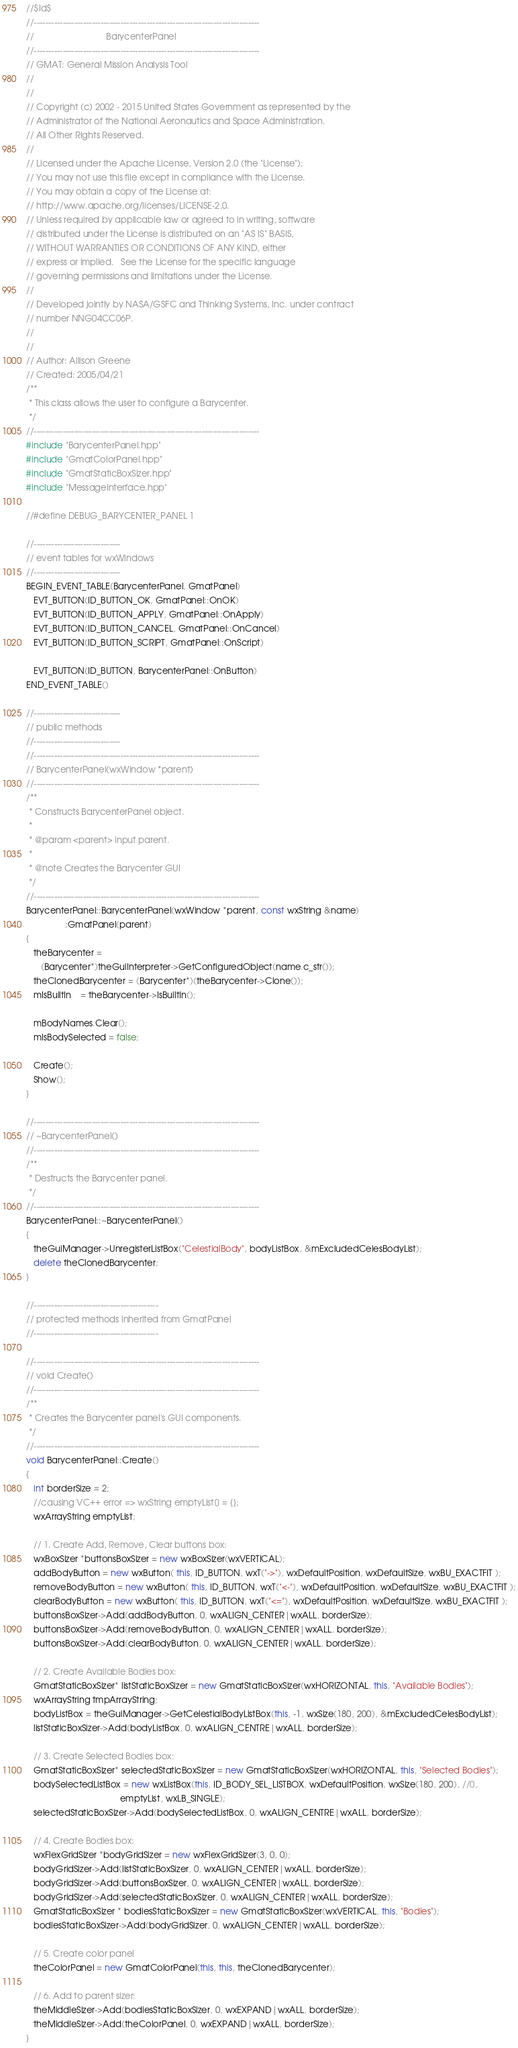Convert code to text. <code><loc_0><loc_0><loc_500><loc_500><_C++_>//$Id$
//------------------------------------------------------------------------------
//                              BarycenterPanel
//------------------------------------------------------------------------------
// GMAT: General Mission Analysis Tool
//
//
// Copyright (c) 2002 - 2015 United States Government as represented by the
// Administrator of the National Aeronautics and Space Administration.
// All Other Rights Reserved.
//
// Licensed under the Apache License, Version 2.0 (the "License"); 
// You may not use this file except in compliance with the License. 
// You may obtain a copy of the License at:
// http://www.apache.org/licenses/LICENSE-2.0. 
// Unless required by applicable law or agreed to in writing, software
// distributed under the License is distributed on an "AS IS" BASIS,
// WITHOUT WARRANTIES OR CONDITIONS OF ANY KIND, either 
// express or implied.   See the License for the specific language
// governing permissions and limitations under the License.
//
// Developed jointly by NASA/GSFC and Thinking Systems, Inc. under contract
// number NNG04CC06P.
//
//
// Author: Allison Greene
// Created: 2005/04/21
/**
 * This class allows the user to configure a Barycenter.
 */
//------------------------------------------------------------------------------
#include "BarycenterPanel.hpp"
#include "GmatColorPanel.hpp"
#include "GmatStaticBoxSizer.hpp"
#include "MessageInterface.hpp"

//#define DEBUG_BARYCENTER_PANEL 1

//------------------------------
// event tables for wxWindows
//------------------------------
BEGIN_EVENT_TABLE(BarycenterPanel, GmatPanel)
   EVT_BUTTON(ID_BUTTON_OK, GmatPanel::OnOK)
   EVT_BUTTON(ID_BUTTON_APPLY, GmatPanel::OnApply)
   EVT_BUTTON(ID_BUTTON_CANCEL, GmatPanel::OnCancel)
   EVT_BUTTON(ID_BUTTON_SCRIPT, GmatPanel::OnScript)

   EVT_BUTTON(ID_BUTTON, BarycenterPanel::OnButton)
END_EVENT_TABLE()

//------------------------------
// public methods
//------------------------------
//------------------------------------------------------------------------------
// BarycenterPanel(wxWindow *parent)
//------------------------------------------------------------------------------
/**
 * Constructs BarycenterPanel object.
 *
 * @param <parent> input parent.
 *
 * @note Creates the Barycenter GUI
 */
//------------------------------------------------------------------------------
BarycenterPanel::BarycenterPanel(wxWindow *parent, const wxString &name)
                :GmatPanel(parent)
{
   theBarycenter =
      (Barycenter*)theGuiInterpreter->GetConfiguredObject(name.c_str());
   theClonedBarycenter = (Barycenter*)(theBarycenter->Clone());
   mIsBuiltIn    = theBarycenter->IsBuiltIn();
   
   mBodyNames.Clear();
   mIsBodySelected = false;
   
   Create();
   Show();
}

//------------------------------------------------------------------------------
// ~BarycenterPanel()
//------------------------------------------------------------------------------
/**
 * Destructs the Barycenter panel.
 */
//------------------------------------------------------------------------------
BarycenterPanel::~BarycenterPanel()
{
   theGuiManager->UnregisterListBox("CelestialBody", bodyListBox, &mExcludedCelesBodyList);
   delete theClonedBarycenter;
}

//-------------------------------------------
// protected methods inherited from GmatPanel
//-------------------------------------------

//------------------------------------------------------------------------------
// void Create()
//------------------------------------------------------------------------------
/**
 * Creates the Barycenter panel's GUI components.
 */
//------------------------------------------------------------------------------
void BarycenterPanel::Create()
{
   int borderSize = 2;
   //causing VC++ error => wxString emptyList[] = {};
   wxArrayString emptyList;
   
   // 1. Create Add, Remove, Clear buttons box:
   wxBoxSizer *buttonsBoxSizer = new wxBoxSizer(wxVERTICAL);
   addBodyButton = new wxButton( this, ID_BUTTON, wxT("->"), wxDefaultPosition, wxDefaultSize, wxBU_EXACTFIT );
   removeBodyButton = new wxButton( this, ID_BUTTON, wxT("<-"), wxDefaultPosition, wxDefaultSize, wxBU_EXACTFIT );
   clearBodyButton = new wxButton( this, ID_BUTTON, wxT("<="), wxDefaultPosition, wxDefaultSize, wxBU_EXACTFIT );
   buttonsBoxSizer->Add(addBodyButton, 0, wxALIGN_CENTER|wxALL, borderSize);
   buttonsBoxSizer->Add(removeBodyButton, 0, wxALIGN_CENTER|wxALL, borderSize);
   buttonsBoxSizer->Add(clearBodyButton, 0, wxALIGN_CENTER|wxALL, borderSize);
   
   // 2. Create Available Bodies box:
   GmatStaticBoxSizer* listStaticBoxSizer = new GmatStaticBoxSizer(wxHORIZONTAL, this, "Available Bodies");
   wxArrayString tmpArrayString;
   bodyListBox = theGuiManager->GetCelestialBodyListBox(this, -1, wxSize(180, 200), &mExcludedCelesBodyList);
   listStaticBoxSizer->Add(bodyListBox, 0, wxALIGN_CENTRE|wxALL, borderSize);
   
   // 3. Create Selected Bodies box:
   GmatStaticBoxSizer* selectedStaticBoxSizer = new GmatStaticBoxSizer(wxHORIZONTAL, this, "Selected Bodies");
   bodySelectedListBox = new wxListBox(this, ID_BODY_SEL_LISTBOX, wxDefaultPosition, wxSize(180, 200), //0,
                                       emptyList, wxLB_SINGLE);
   selectedStaticBoxSizer->Add(bodySelectedListBox, 0, wxALIGN_CENTRE|wxALL, borderSize);
   
   // 4. Create Bodies box:
   wxFlexGridSizer *bodyGridSizer = new wxFlexGridSizer(3, 0, 0);
   bodyGridSizer->Add(listStaticBoxSizer, 0, wxALIGN_CENTER|wxALL, borderSize);
   bodyGridSizer->Add(buttonsBoxSizer, 0, wxALIGN_CENTER|wxALL, borderSize);
   bodyGridSizer->Add(selectedStaticBoxSizer, 0, wxALIGN_CENTER|wxALL, borderSize);
   GmatStaticBoxSizer * bodiesStaticBoxSizer = new GmatStaticBoxSizer(wxVERTICAL, this, "Bodies");
   bodiesStaticBoxSizer->Add(bodyGridSizer, 0, wxALIGN_CENTER|wxALL, borderSize);
   
   // 5. Create color panel
   theColorPanel = new GmatColorPanel(this, this, theClonedBarycenter);
   
   // 6. Add to parent sizer:
   theMiddleSizer->Add(bodiesStaticBoxSizer, 0, wxEXPAND|wxALL, borderSize);
   theMiddleSizer->Add(theColorPanel, 0, wxEXPAND|wxALL, borderSize);
}

</code> 